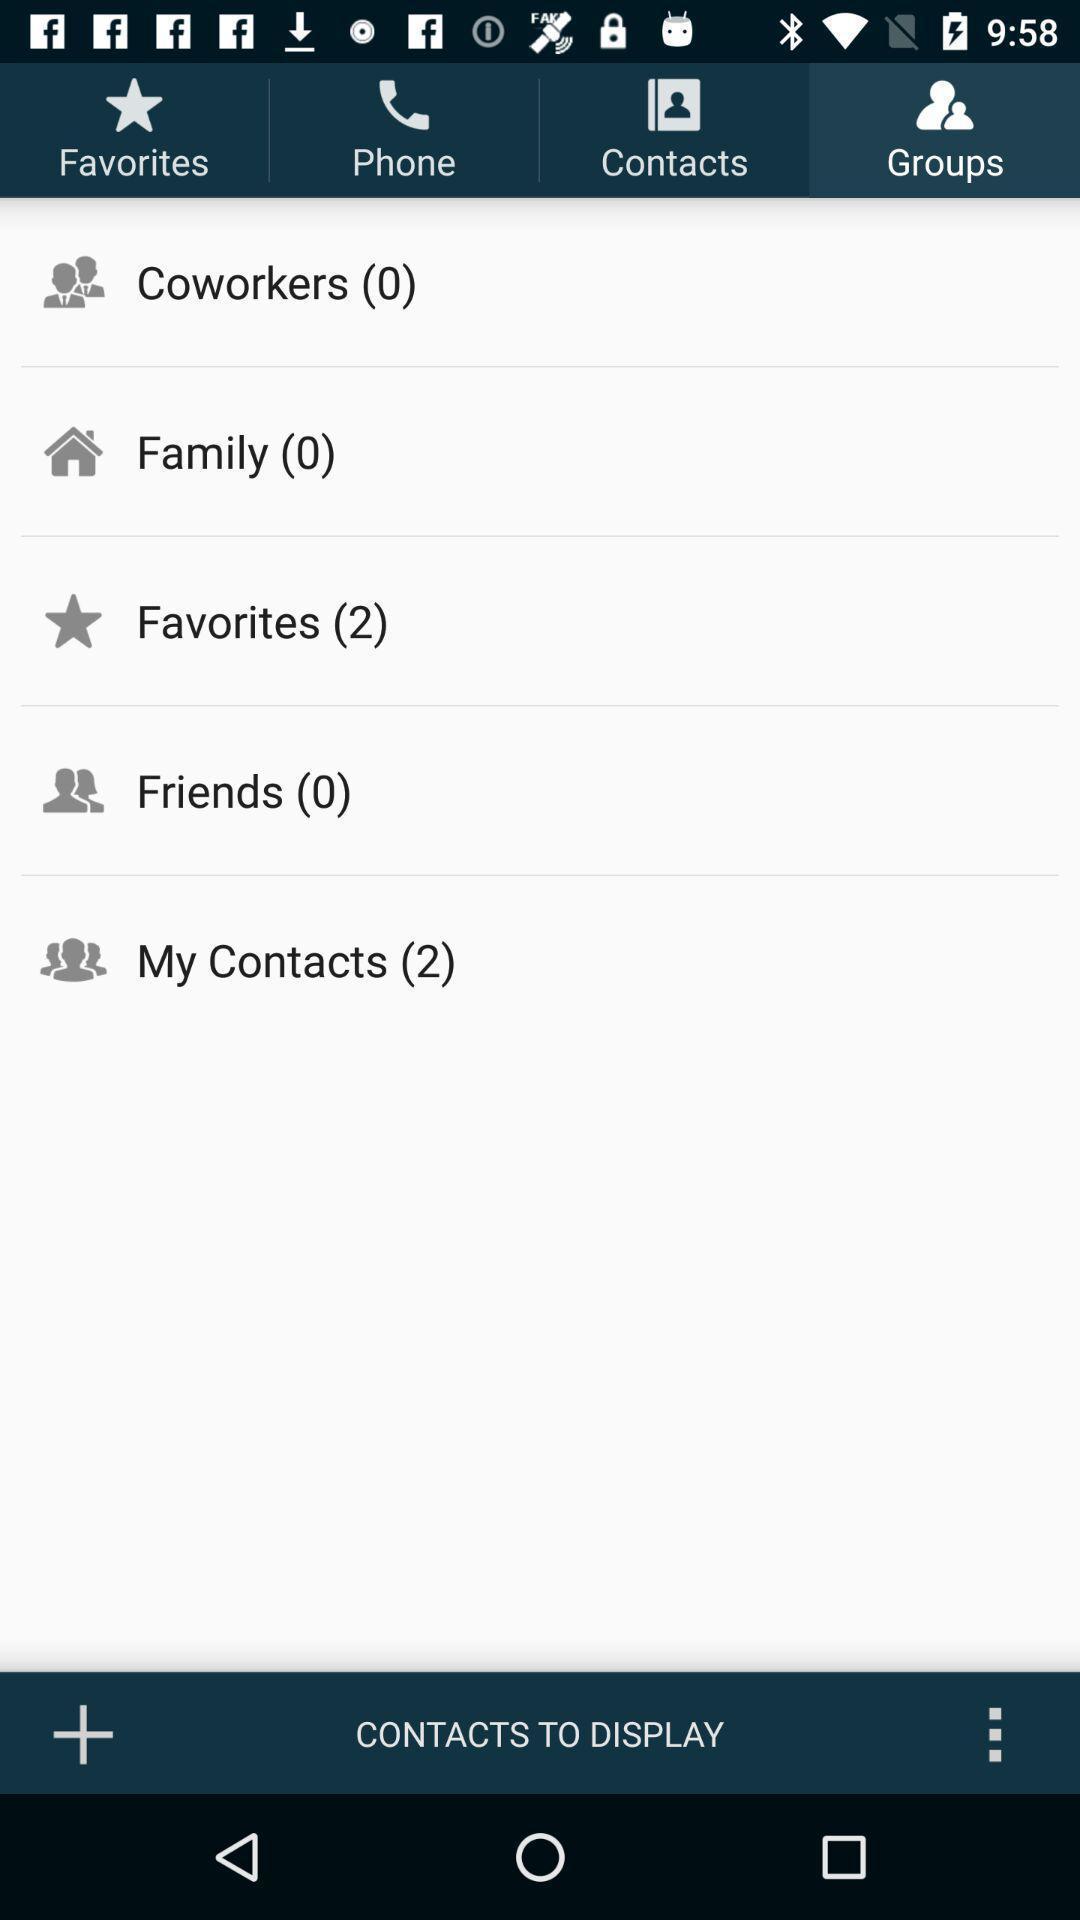What is the overall content of this screenshot? Page showing list of different groups in the contacts app. 